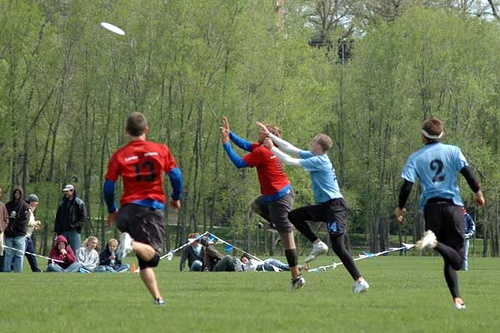Describe the objects in this image and their specific colors. I can see people in olive, black, maroon, brown, and gray tones, people in olive, black, gray, and teal tones, people in olive, black, gray, white, and darkgray tones, people in olive, black, maroon, gray, and brown tones, and people in olive, black, gray, blue, and darkgray tones in this image. 